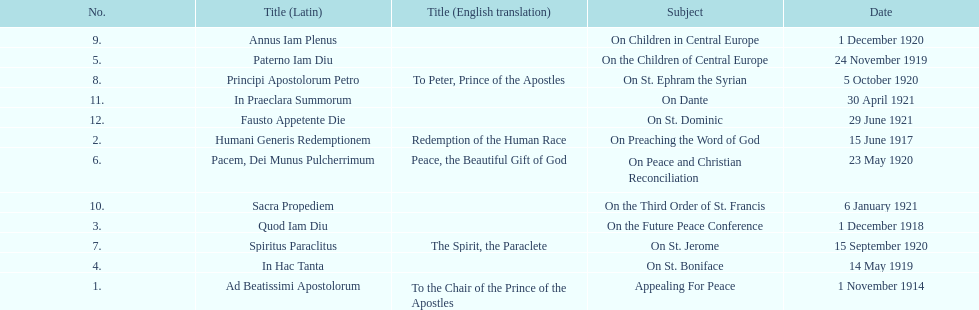How long after quod iam diu was paterno iam diu issued? 11 months. 